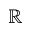Convert formula to latex. <formula><loc_0><loc_0><loc_500><loc_500>\mathbb { R }</formula> 